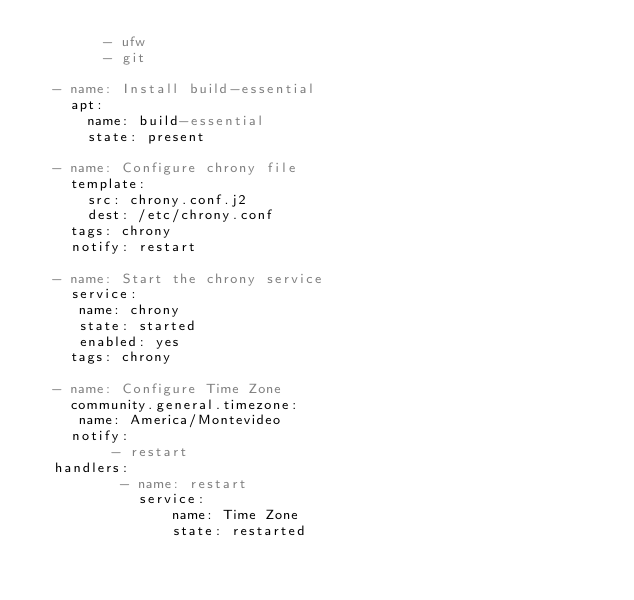Convert code to text. <code><loc_0><loc_0><loc_500><loc_500><_YAML_>        - ufw
        - git
  
  - name: Install build-essential
    apt:
      name: build-essential 
      state: present
      
  - name: Configure chrony file
    template:
      src: chrony.conf.j2
      dest: /etc/chrony.conf
    tags: chrony
    notify: restart 
    
  - name: Start the chrony service
    service:
     name: chrony
     state: started
     enabled: yes
    tags: chrony
    
  - name: Configure Time Zone
    community.general.timezone:
     name: America/Montevideo
    notify: 
         - restart 
  handlers:
          - name: restart 
            service: 
                name: Time Zone
                state: restarted
                  </code> 